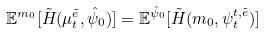<formula> <loc_0><loc_0><loc_500><loc_500>\mathbb { E } ^ { m _ { 0 } } [ \tilde { H } ( \mu _ { t } ^ { \tilde { e } } , \hat { \psi } _ { 0 } ) ] = \mathbb { E } ^ { \hat { \psi } _ { 0 } } [ \tilde { H } ( m _ { 0 } , \psi _ { t } ^ { t , \tilde { e } } ) ]</formula> 